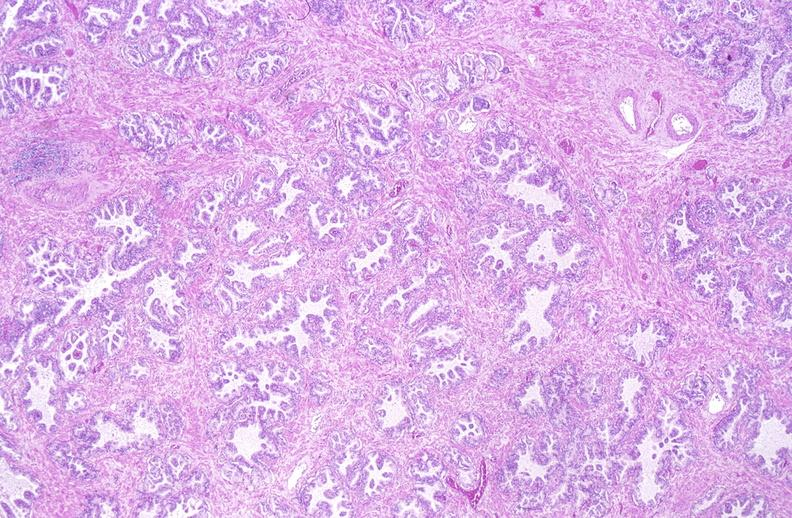what does this image show?
Answer the question using a single word or phrase. Normal prostate 